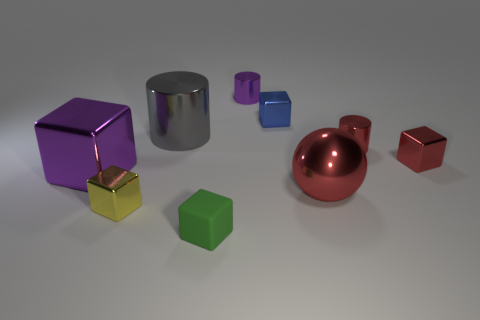Add 1 big green matte balls. How many objects exist? 10 Subtract all red blocks. How many blocks are left? 4 Subtract all cylinders. How many objects are left? 6 Subtract 1 balls. How many balls are left? 0 Add 5 blue metal blocks. How many blue metal blocks are left? 6 Add 2 red blocks. How many red blocks exist? 3 Subtract all green cubes. How many cubes are left? 4 Subtract 0 blue balls. How many objects are left? 9 Subtract all red cylinders. Subtract all green balls. How many cylinders are left? 2 Subtract all brown cylinders. How many blue cubes are left? 1 